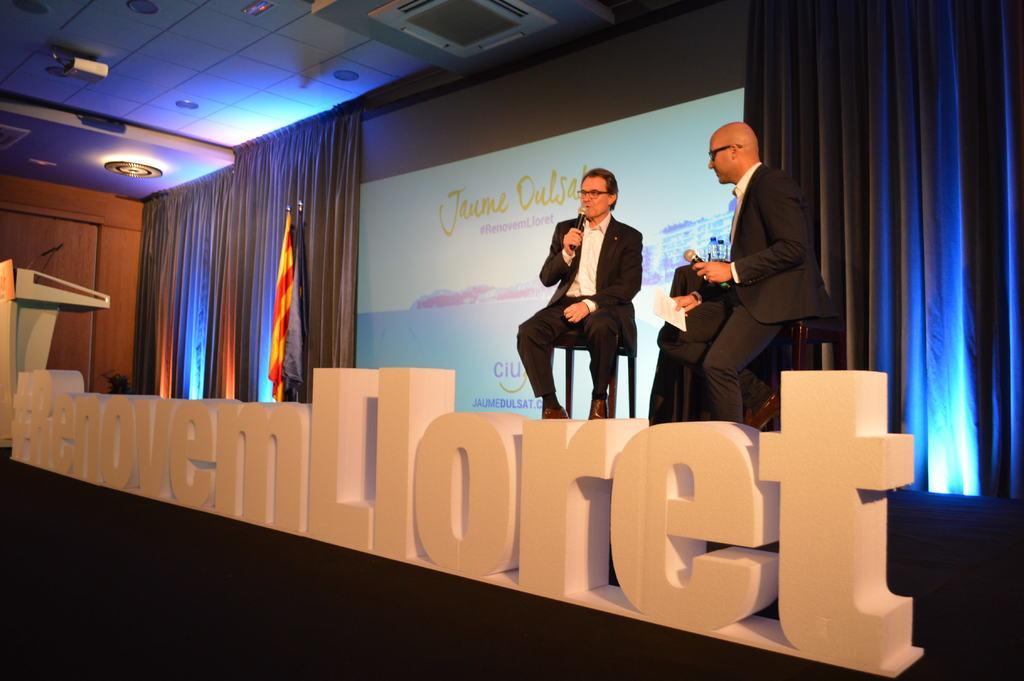Can you describe this image briefly? At the bottom of the image we can see some text. In the middle of the image two persons are sitting and holding microphones and papers. Behind them we can see a table, on the table we can see two bottles and we can see two flags. Behind them we can see a wall, on the wall we can see a screen and curtain. At the top of the image we can see ceiling, lights and projector. In the bottom left corner of the image we can see a podium, on the podium we can see a microphone. 